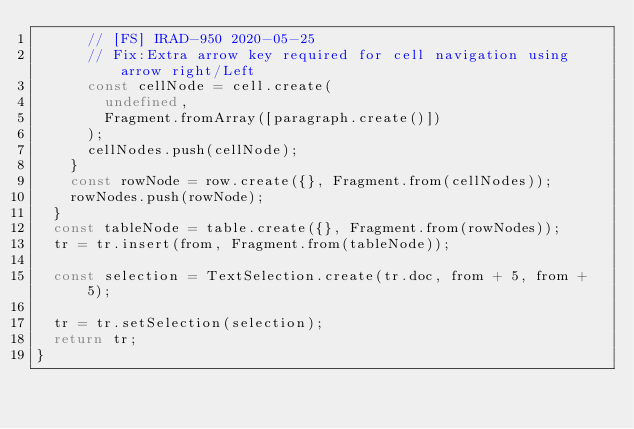Convert code to text. <code><loc_0><loc_0><loc_500><loc_500><_JavaScript_>      // [FS] IRAD-950 2020-05-25
      // Fix:Extra arrow key required for cell navigation using arrow right/Left
      const cellNode = cell.create(
        undefined,
        Fragment.fromArray([paragraph.create()])
      );
      cellNodes.push(cellNode);
    }
    const rowNode = row.create({}, Fragment.from(cellNodes));
    rowNodes.push(rowNode);
  }
  const tableNode = table.create({}, Fragment.from(rowNodes));
  tr = tr.insert(from, Fragment.from(tableNode));

  const selection = TextSelection.create(tr.doc, from + 5, from + 5);

  tr = tr.setSelection(selection);
  return tr;
}
</code> 